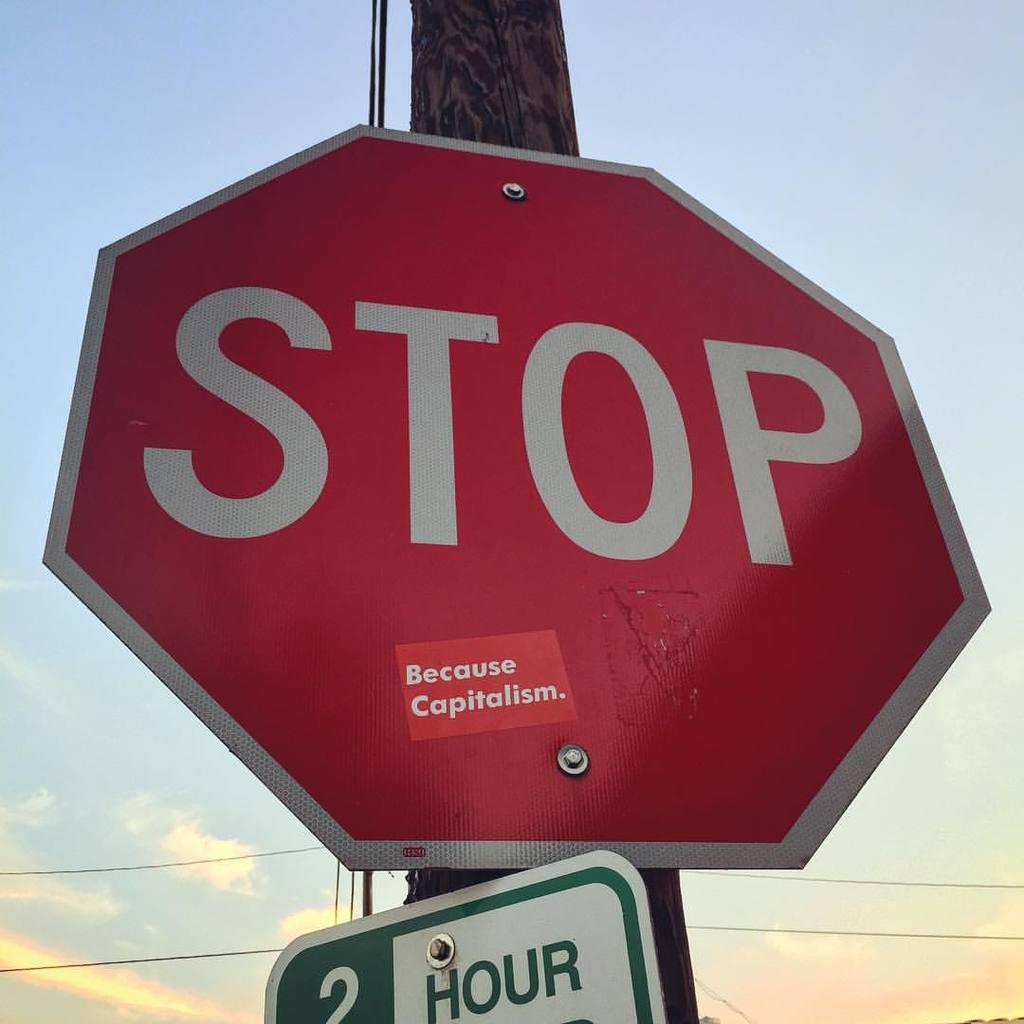What does the sign say to do?
Your answer should be compact. Stop. What is written on the board below the stop sign?
Keep it short and to the point. Because capitalism. 